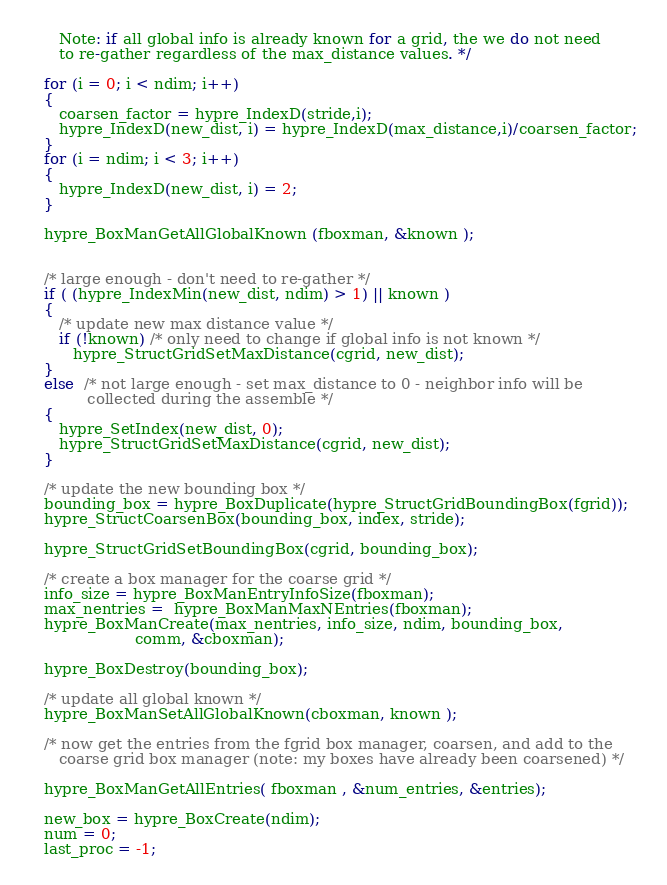<code> <loc_0><loc_0><loc_500><loc_500><_C_>      Note: if all global info is already known for a grid, the we do not need
      to re-gather regardless of the max_distance values. */

   for (i = 0; i < ndim; i++)
   {
      coarsen_factor = hypre_IndexD(stride,i); 
      hypre_IndexD(new_dist, i) = hypre_IndexD(max_distance,i)/coarsen_factor;
   }
   for (i = ndim; i < 3; i++)
   {
      hypre_IndexD(new_dist, i) = 2;
   }
   
   hypre_BoxManGetAllGlobalKnown (fboxman, &known );


   /* large enough - don't need to re-gather */
   if ( (hypre_IndexMin(new_dist, ndim) > 1) || known )
   {
      /* update new max distance value */  
      if (!known) /* only need to change if global info is not known */
         hypre_StructGridSetMaxDistance(cgrid, new_dist);
   }
   else  /* not large enough - set max_distance to 0 - neighbor info will be
            collected during the assemble */
   {
      hypre_SetIndex(new_dist, 0);
      hypre_StructGridSetMaxDistance(cgrid, new_dist);
   }

   /* update the new bounding box */
   bounding_box = hypre_BoxDuplicate(hypre_StructGridBoundingBox(fgrid));
   hypre_StructCoarsenBox(bounding_box, index, stride);
   
   hypre_StructGridSetBoundingBox(cgrid, bounding_box);
   
   /* create a box manager for the coarse grid */ 
   info_size = hypre_BoxManEntryInfoSize(fboxman);
   max_nentries =  hypre_BoxManMaxNEntries(fboxman);
   hypre_BoxManCreate(max_nentries, info_size, ndim, bounding_box, 
                      comm, &cboxman);
   
   hypre_BoxDestroy(bounding_box);
   
   /* update all global known */
   hypre_BoxManSetAllGlobalKnown(cboxman, known );
   
   /* now get the entries from the fgrid box manager, coarsen, and add to the
      coarse grid box manager (note: my boxes have already been coarsened) */
   
   hypre_BoxManGetAllEntries( fboxman , &num_entries, &entries); 

   new_box = hypre_BoxCreate(ndim);
   num = 0;
   last_proc = -1;
</code> 